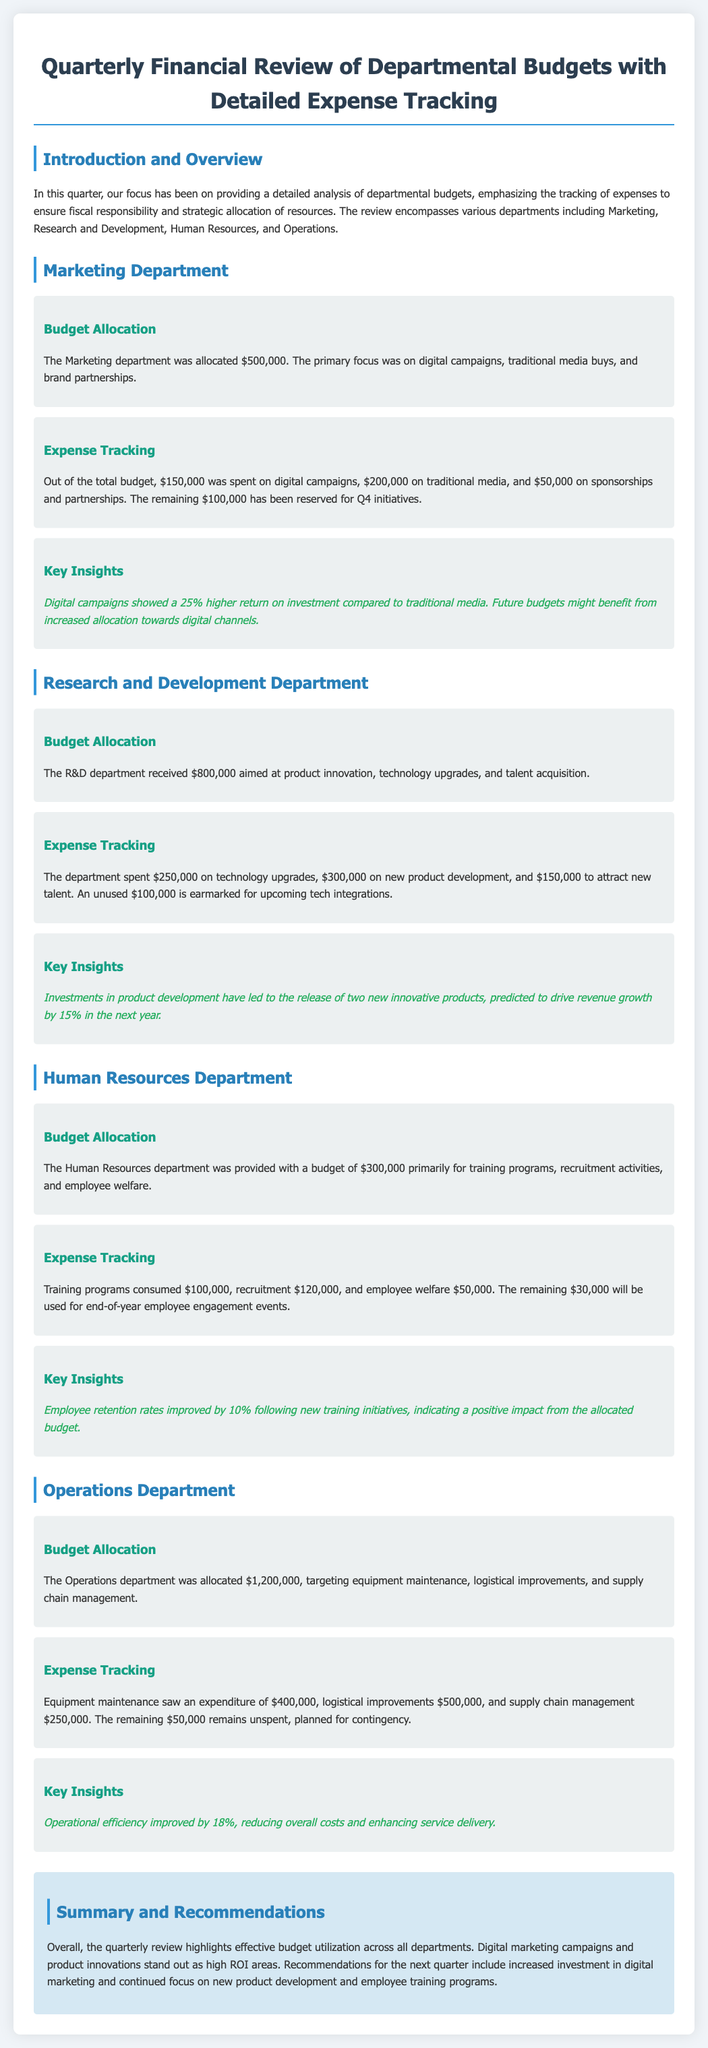What was the budget allocation for the Marketing department? The budget allocation for the Marketing department is specifically stated in the document, which is $500,000.
Answer: $500,000 How much was spent on digital campaigns by the Marketing department? The document provides a breakdown of expenses for the Marketing department, indicating that $150,000 was spent on digital campaigns.
Answer: $150,000 What is the key insight for the Research and Development department? The document outlines insights for each department, and the key insight for R&D is that investments in product development led to new products that are projected to increase revenue by 15%.
Answer: 15% What was the total budget for the Human Resources department? The document specifies the total budget allocated to the Human Resources department, which is $300,000.
Answer: $300,000 How much money remained unspent in the Operations department? The expense tracking section for the Operations department reveals that $50,000 remained unspent.
Answer: $50,000 Which department aimed to improve operational efficiency? The document cites the Operations department's focus on enhancing operational efficiency as part of its budget allocation.
Answer: Operations department What was the primary focus of the Marketing department's budget? The document explains that the Marketing department's primary focus was on digital campaigns, traditional media buys, and brand partnerships.
Answer: Digital campaigns, traditional media buys, and brand partnerships What percentage increase in employee retention is noted for the Human Resources department? A key insight in the Human Resources section states that employee retention rates improved by 10% due to new training initiatives.
Answer: 10% What was the unused budget amount for the Research and Development department? The R&D section indicates that there is an unused budget of $100,000 earmarked for upcoming tech integrations.
Answer: $100,000 